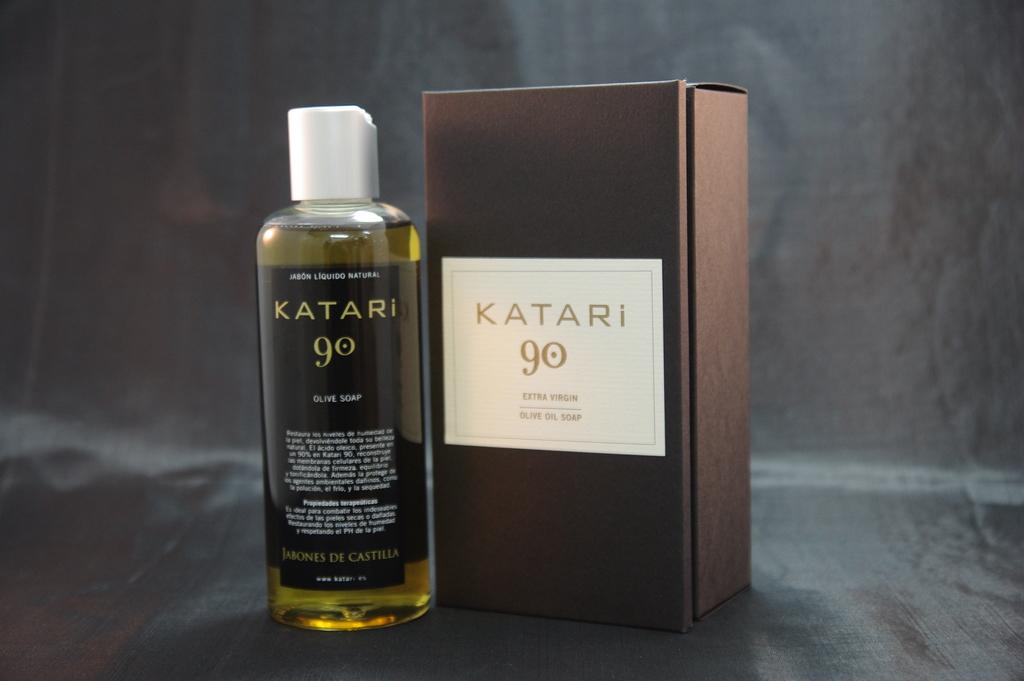What number katari is this?
Your answer should be very brief. 90. What is the brand of product?
Provide a succinct answer. Katari. 